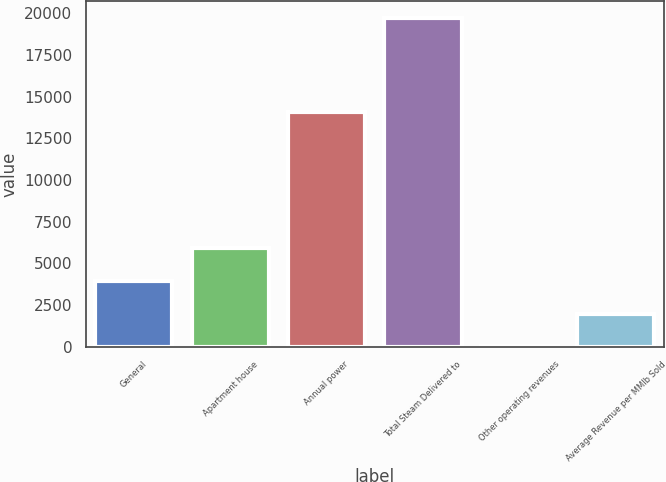Convert chart. <chart><loc_0><loc_0><loc_500><loc_500><bar_chart><fcel>General<fcel>Apartment house<fcel>Annual power<fcel>Total Steam Delivered to<fcel>Other operating revenues<fcel>Average Revenue per MMlb Sold<nl><fcel>3961<fcel>5933.5<fcel>14076<fcel>19741<fcel>16<fcel>1988.5<nl></chart> 